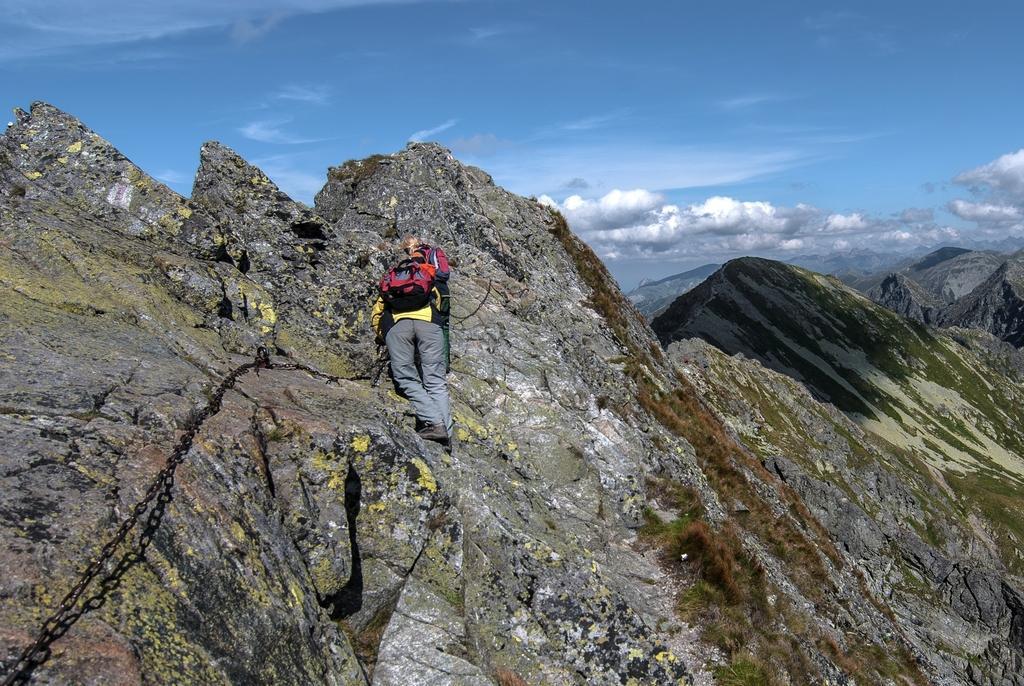In one or two sentences, can you explain what this image depicts? In this picture I can see a person climbing the hill, on the right side there are hills. At the top there is the sky, on the left I can see the chain. 